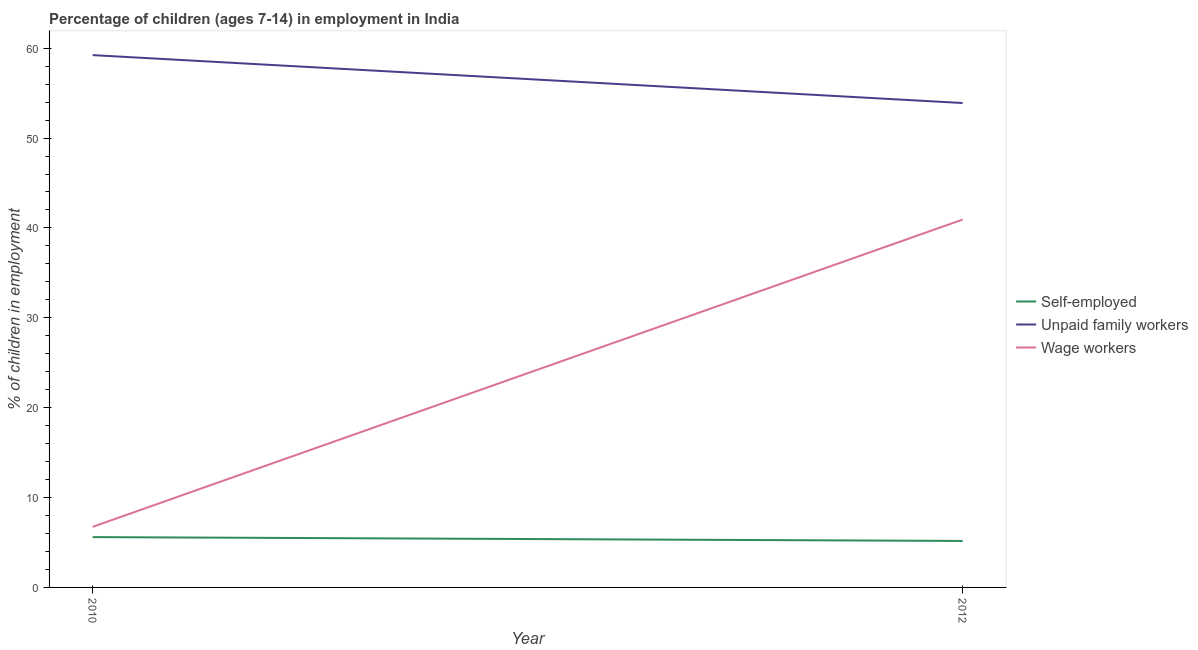Is the number of lines equal to the number of legend labels?
Ensure brevity in your answer.  Yes. What is the percentage of children employed as unpaid family workers in 2012?
Your response must be concise. 53.9. Across all years, what is the maximum percentage of children employed as wage workers?
Keep it short and to the point. 40.93. Across all years, what is the minimum percentage of children employed as wage workers?
Offer a terse response. 6.74. In which year was the percentage of children employed as unpaid family workers minimum?
Your answer should be very brief. 2012. What is the total percentage of children employed as wage workers in the graph?
Ensure brevity in your answer.  47.67. What is the difference between the percentage of children employed as wage workers in 2010 and that in 2012?
Give a very brief answer. -34.19. What is the difference between the percentage of self employed children in 2010 and the percentage of children employed as unpaid family workers in 2012?
Offer a very short reply. -48.3. What is the average percentage of self employed children per year?
Your response must be concise. 5.38. In the year 2010, what is the difference between the percentage of self employed children and percentage of children employed as wage workers?
Give a very brief answer. -1.14. What is the ratio of the percentage of self employed children in 2010 to that in 2012?
Make the answer very short. 1.08. Is the percentage of self employed children in 2010 less than that in 2012?
Give a very brief answer. No. Is it the case that in every year, the sum of the percentage of self employed children and percentage of children employed as unpaid family workers is greater than the percentage of children employed as wage workers?
Your answer should be compact. Yes. Does the percentage of children employed as unpaid family workers monotonically increase over the years?
Ensure brevity in your answer.  No. How many lines are there?
Offer a terse response. 3. How many years are there in the graph?
Your response must be concise. 2. Are the values on the major ticks of Y-axis written in scientific E-notation?
Give a very brief answer. No. Does the graph contain grids?
Ensure brevity in your answer.  No. How many legend labels are there?
Ensure brevity in your answer.  3. How are the legend labels stacked?
Your response must be concise. Vertical. What is the title of the graph?
Give a very brief answer. Percentage of children (ages 7-14) in employment in India. What is the label or title of the Y-axis?
Your response must be concise. % of children in employment. What is the % of children in employment of Self-employed in 2010?
Your response must be concise. 5.6. What is the % of children in employment of Unpaid family workers in 2010?
Your answer should be compact. 59.23. What is the % of children in employment in Wage workers in 2010?
Your answer should be compact. 6.74. What is the % of children in employment in Self-employed in 2012?
Provide a succinct answer. 5.17. What is the % of children in employment in Unpaid family workers in 2012?
Offer a very short reply. 53.9. What is the % of children in employment of Wage workers in 2012?
Offer a very short reply. 40.93. Across all years, what is the maximum % of children in employment in Self-employed?
Provide a succinct answer. 5.6. Across all years, what is the maximum % of children in employment of Unpaid family workers?
Give a very brief answer. 59.23. Across all years, what is the maximum % of children in employment in Wage workers?
Make the answer very short. 40.93. Across all years, what is the minimum % of children in employment of Self-employed?
Offer a terse response. 5.17. Across all years, what is the minimum % of children in employment of Unpaid family workers?
Make the answer very short. 53.9. Across all years, what is the minimum % of children in employment in Wage workers?
Keep it short and to the point. 6.74. What is the total % of children in employment of Self-employed in the graph?
Offer a very short reply. 10.77. What is the total % of children in employment in Unpaid family workers in the graph?
Your answer should be very brief. 113.13. What is the total % of children in employment in Wage workers in the graph?
Your answer should be very brief. 47.67. What is the difference between the % of children in employment in Self-employed in 2010 and that in 2012?
Ensure brevity in your answer.  0.43. What is the difference between the % of children in employment of Unpaid family workers in 2010 and that in 2012?
Provide a succinct answer. 5.33. What is the difference between the % of children in employment of Wage workers in 2010 and that in 2012?
Provide a succinct answer. -34.19. What is the difference between the % of children in employment of Self-employed in 2010 and the % of children in employment of Unpaid family workers in 2012?
Offer a very short reply. -48.3. What is the difference between the % of children in employment in Self-employed in 2010 and the % of children in employment in Wage workers in 2012?
Give a very brief answer. -35.33. What is the difference between the % of children in employment of Unpaid family workers in 2010 and the % of children in employment of Wage workers in 2012?
Ensure brevity in your answer.  18.3. What is the average % of children in employment in Self-employed per year?
Your answer should be compact. 5.38. What is the average % of children in employment of Unpaid family workers per year?
Your response must be concise. 56.56. What is the average % of children in employment of Wage workers per year?
Ensure brevity in your answer.  23.84. In the year 2010, what is the difference between the % of children in employment of Self-employed and % of children in employment of Unpaid family workers?
Provide a short and direct response. -53.63. In the year 2010, what is the difference between the % of children in employment in Self-employed and % of children in employment in Wage workers?
Give a very brief answer. -1.14. In the year 2010, what is the difference between the % of children in employment in Unpaid family workers and % of children in employment in Wage workers?
Your answer should be compact. 52.49. In the year 2012, what is the difference between the % of children in employment of Self-employed and % of children in employment of Unpaid family workers?
Offer a very short reply. -48.73. In the year 2012, what is the difference between the % of children in employment of Self-employed and % of children in employment of Wage workers?
Ensure brevity in your answer.  -35.76. In the year 2012, what is the difference between the % of children in employment of Unpaid family workers and % of children in employment of Wage workers?
Your answer should be compact. 12.97. What is the ratio of the % of children in employment of Self-employed in 2010 to that in 2012?
Your answer should be very brief. 1.08. What is the ratio of the % of children in employment in Unpaid family workers in 2010 to that in 2012?
Your answer should be compact. 1.1. What is the ratio of the % of children in employment of Wage workers in 2010 to that in 2012?
Give a very brief answer. 0.16. What is the difference between the highest and the second highest % of children in employment of Self-employed?
Your answer should be compact. 0.43. What is the difference between the highest and the second highest % of children in employment in Unpaid family workers?
Your answer should be very brief. 5.33. What is the difference between the highest and the second highest % of children in employment in Wage workers?
Ensure brevity in your answer.  34.19. What is the difference between the highest and the lowest % of children in employment in Self-employed?
Give a very brief answer. 0.43. What is the difference between the highest and the lowest % of children in employment in Unpaid family workers?
Give a very brief answer. 5.33. What is the difference between the highest and the lowest % of children in employment of Wage workers?
Make the answer very short. 34.19. 